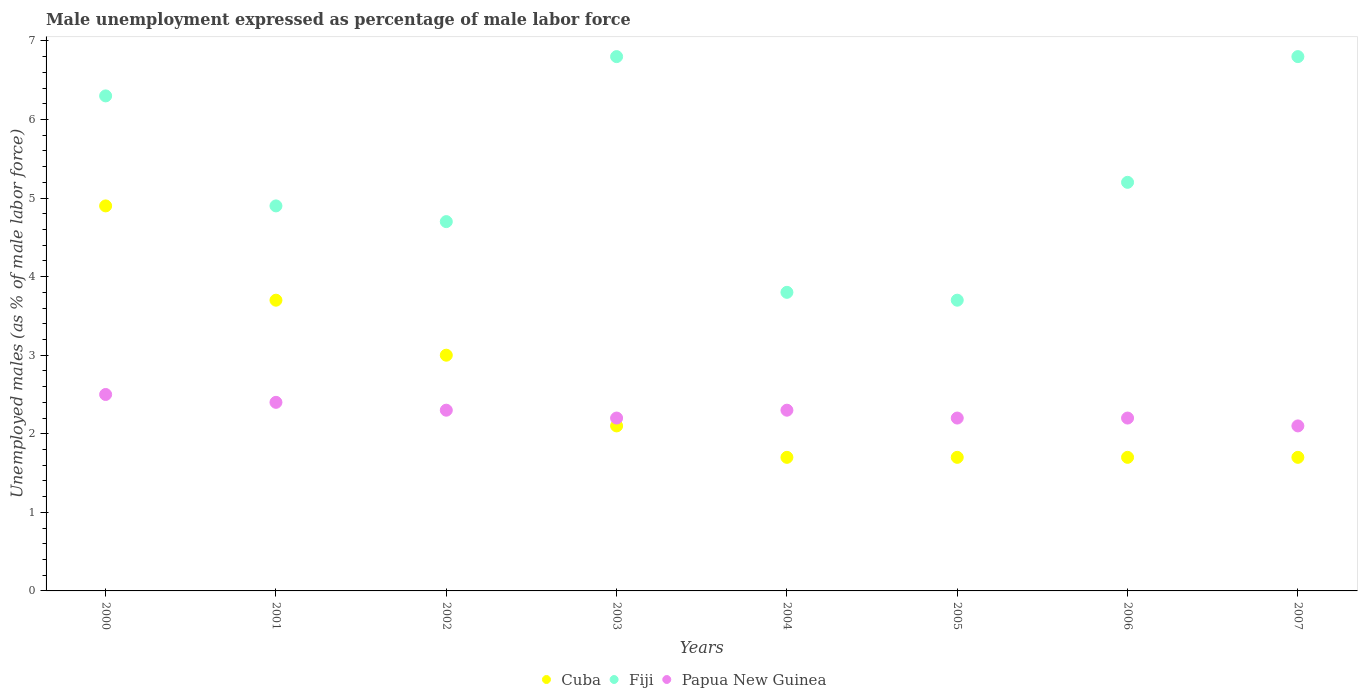How many different coloured dotlines are there?
Your answer should be compact. 3. What is the unemployment in males in in Cuba in 2003?
Give a very brief answer. 2.1. Across all years, what is the maximum unemployment in males in in Fiji?
Offer a terse response. 6.8. Across all years, what is the minimum unemployment in males in in Papua New Guinea?
Provide a succinct answer. 2.1. In which year was the unemployment in males in in Cuba maximum?
Offer a very short reply. 2000. In which year was the unemployment in males in in Fiji minimum?
Provide a short and direct response. 2005. What is the total unemployment in males in in Cuba in the graph?
Offer a very short reply. 20.5. What is the difference between the unemployment in males in in Fiji in 2000 and that in 2001?
Provide a succinct answer. 1.4. What is the difference between the unemployment in males in in Cuba in 2006 and the unemployment in males in in Papua New Guinea in 2005?
Offer a very short reply. -0.5. What is the average unemployment in males in in Papua New Guinea per year?
Your response must be concise. 2.28. In the year 2005, what is the difference between the unemployment in males in in Cuba and unemployment in males in in Papua New Guinea?
Make the answer very short. -0.5. What is the ratio of the unemployment in males in in Cuba in 2002 to that in 2005?
Make the answer very short. 1.76. What is the difference between the highest and the second highest unemployment in males in in Fiji?
Your answer should be very brief. 0. What is the difference between the highest and the lowest unemployment in males in in Fiji?
Make the answer very short. 3.1. Is the sum of the unemployment in males in in Fiji in 2005 and 2006 greater than the maximum unemployment in males in in Papua New Guinea across all years?
Provide a short and direct response. Yes. Where does the legend appear in the graph?
Ensure brevity in your answer.  Bottom center. How many legend labels are there?
Provide a succinct answer. 3. What is the title of the graph?
Keep it short and to the point. Male unemployment expressed as percentage of male labor force. Does "Sub-Saharan Africa (developing only)" appear as one of the legend labels in the graph?
Provide a succinct answer. No. What is the label or title of the X-axis?
Your answer should be very brief. Years. What is the label or title of the Y-axis?
Make the answer very short. Unemployed males (as % of male labor force). What is the Unemployed males (as % of male labor force) in Cuba in 2000?
Give a very brief answer. 4.9. What is the Unemployed males (as % of male labor force) in Fiji in 2000?
Your answer should be very brief. 6.3. What is the Unemployed males (as % of male labor force) of Papua New Guinea in 2000?
Make the answer very short. 2.5. What is the Unemployed males (as % of male labor force) of Cuba in 2001?
Your answer should be very brief. 3.7. What is the Unemployed males (as % of male labor force) of Fiji in 2001?
Your response must be concise. 4.9. What is the Unemployed males (as % of male labor force) in Papua New Guinea in 2001?
Your response must be concise. 2.4. What is the Unemployed males (as % of male labor force) in Cuba in 2002?
Make the answer very short. 3. What is the Unemployed males (as % of male labor force) of Fiji in 2002?
Ensure brevity in your answer.  4.7. What is the Unemployed males (as % of male labor force) of Papua New Guinea in 2002?
Keep it short and to the point. 2.3. What is the Unemployed males (as % of male labor force) in Cuba in 2003?
Make the answer very short. 2.1. What is the Unemployed males (as % of male labor force) of Fiji in 2003?
Your answer should be very brief. 6.8. What is the Unemployed males (as % of male labor force) of Papua New Guinea in 2003?
Ensure brevity in your answer.  2.2. What is the Unemployed males (as % of male labor force) in Cuba in 2004?
Your answer should be compact. 1.7. What is the Unemployed males (as % of male labor force) in Fiji in 2004?
Give a very brief answer. 3.8. What is the Unemployed males (as % of male labor force) in Papua New Guinea in 2004?
Offer a very short reply. 2.3. What is the Unemployed males (as % of male labor force) of Cuba in 2005?
Your response must be concise. 1.7. What is the Unemployed males (as % of male labor force) of Fiji in 2005?
Make the answer very short. 3.7. What is the Unemployed males (as % of male labor force) in Papua New Guinea in 2005?
Make the answer very short. 2.2. What is the Unemployed males (as % of male labor force) of Cuba in 2006?
Offer a terse response. 1.7. What is the Unemployed males (as % of male labor force) in Fiji in 2006?
Make the answer very short. 5.2. What is the Unemployed males (as % of male labor force) of Papua New Guinea in 2006?
Your answer should be very brief. 2.2. What is the Unemployed males (as % of male labor force) in Cuba in 2007?
Ensure brevity in your answer.  1.7. What is the Unemployed males (as % of male labor force) of Fiji in 2007?
Your response must be concise. 6.8. What is the Unemployed males (as % of male labor force) of Papua New Guinea in 2007?
Your answer should be compact. 2.1. Across all years, what is the maximum Unemployed males (as % of male labor force) in Cuba?
Keep it short and to the point. 4.9. Across all years, what is the maximum Unemployed males (as % of male labor force) of Fiji?
Offer a very short reply. 6.8. Across all years, what is the minimum Unemployed males (as % of male labor force) of Cuba?
Provide a short and direct response. 1.7. Across all years, what is the minimum Unemployed males (as % of male labor force) in Fiji?
Make the answer very short. 3.7. Across all years, what is the minimum Unemployed males (as % of male labor force) in Papua New Guinea?
Your answer should be very brief. 2.1. What is the total Unemployed males (as % of male labor force) of Cuba in the graph?
Make the answer very short. 20.5. What is the total Unemployed males (as % of male labor force) of Fiji in the graph?
Provide a succinct answer. 42.2. What is the difference between the Unemployed males (as % of male labor force) of Fiji in 2000 and that in 2001?
Provide a succinct answer. 1.4. What is the difference between the Unemployed males (as % of male labor force) in Papua New Guinea in 2000 and that in 2001?
Keep it short and to the point. 0.1. What is the difference between the Unemployed males (as % of male labor force) in Cuba in 2000 and that in 2002?
Make the answer very short. 1.9. What is the difference between the Unemployed males (as % of male labor force) in Fiji in 2000 and that in 2002?
Offer a terse response. 1.6. What is the difference between the Unemployed males (as % of male labor force) of Papua New Guinea in 2000 and that in 2002?
Your answer should be very brief. 0.2. What is the difference between the Unemployed males (as % of male labor force) in Cuba in 2000 and that in 2004?
Keep it short and to the point. 3.2. What is the difference between the Unemployed males (as % of male labor force) of Fiji in 2000 and that in 2004?
Offer a very short reply. 2.5. What is the difference between the Unemployed males (as % of male labor force) in Papua New Guinea in 2000 and that in 2004?
Your answer should be very brief. 0.2. What is the difference between the Unemployed males (as % of male labor force) of Cuba in 2000 and that in 2005?
Your answer should be compact. 3.2. What is the difference between the Unemployed males (as % of male labor force) of Papua New Guinea in 2000 and that in 2005?
Make the answer very short. 0.3. What is the difference between the Unemployed males (as % of male labor force) of Cuba in 2000 and that in 2006?
Provide a short and direct response. 3.2. What is the difference between the Unemployed males (as % of male labor force) of Cuba in 2000 and that in 2007?
Provide a short and direct response. 3.2. What is the difference between the Unemployed males (as % of male labor force) of Cuba in 2001 and that in 2002?
Give a very brief answer. 0.7. What is the difference between the Unemployed males (as % of male labor force) in Fiji in 2001 and that in 2002?
Provide a short and direct response. 0.2. What is the difference between the Unemployed males (as % of male labor force) in Cuba in 2001 and that in 2003?
Your answer should be compact. 1.6. What is the difference between the Unemployed males (as % of male labor force) in Fiji in 2001 and that in 2004?
Your answer should be compact. 1.1. What is the difference between the Unemployed males (as % of male labor force) of Papua New Guinea in 2001 and that in 2004?
Make the answer very short. 0.1. What is the difference between the Unemployed males (as % of male labor force) in Cuba in 2001 and that in 2005?
Offer a terse response. 2. What is the difference between the Unemployed males (as % of male labor force) of Fiji in 2001 and that in 2005?
Provide a short and direct response. 1.2. What is the difference between the Unemployed males (as % of male labor force) of Cuba in 2001 and that in 2006?
Your answer should be very brief. 2. What is the difference between the Unemployed males (as % of male labor force) in Fiji in 2001 and that in 2007?
Your answer should be very brief. -1.9. What is the difference between the Unemployed males (as % of male labor force) of Fiji in 2002 and that in 2003?
Your response must be concise. -2.1. What is the difference between the Unemployed males (as % of male labor force) in Fiji in 2002 and that in 2004?
Offer a terse response. 0.9. What is the difference between the Unemployed males (as % of male labor force) in Fiji in 2002 and that in 2005?
Keep it short and to the point. 1. What is the difference between the Unemployed males (as % of male labor force) of Papua New Guinea in 2002 and that in 2005?
Provide a succinct answer. 0.1. What is the difference between the Unemployed males (as % of male labor force) in Cuba in 2002 and that in 2006?
Your answer should be very brief. 1.3. What is the difference between the Unemployed males (as % of male labor force) in Fiji in 2002 and that in 2006?
Provide a succinct answer. -0.5. What is the difference between the Unemployed males (as % of male labor force) in Fiji in 2002 and that in 2007?
Offer a very short reply. -2.1. What is the difference between the Unemployed males (as % of male labor force) in Papua New Guinea in 2002 and that in 2007?
Make the answer very short. 0.2. What is the difference between the Unemployed males (as % of male labor force) of Cuba in 2003 and that in 2004?
Make the answer very short. 0.4. What is the difference between the Unemployed males (as % of male labor force) of Papua New Guinea in 2003 and that in 2004?
Provide a short and direct response. -0.1. What is the difference between the Unemployed males (as % of male labor force) of Cuba in 2003 and that in 2005?
Your answer should be compact. 0.4. What is the difference between the Unemployed males (as % of male labor force) in Fiji in 2003 and that in 2005?
Offer a terse response. 3.1. What is the difference between the Unemployed males (as % of male labor force) in Cuba in 2003 and that in 2007?
Give a very brief answer. 0.4. What is the difference between the Unemployed males (as % of male labor force) of Fiji in 2003 and that in 2007?
Provide a succinct answer. 0. What is the difference between the Unemployed males (as % of male labor force) of Papua New Guinea in 2003 and that in 2007?
Your answer should be compact. 0.1. What is the difference between the Unemployed males (as % of male labor force) of Cuba in 2004 and that in 2005?
Your answer should be compact. 0. What is the difference between the Unemployed males (as % of male labor force) of Fiji in 2004 and that in 2005?
Ensure brevity in your answer.  0.1. What is the difference between the Unemployed males (as % of male labor force) in Papua New Guinea in 2004 and that in 2005?
Your answer should be compact. 0.1. What is the difference between the Unemployed males (as % of male labor force) of Papua New Guinea in 2004 and that in 2006?
Give a very brief answer. 0.1. What is the difference between the Unemployed males (as % of male labor force) in Cuba in 2004 and that in 2007?
Provide a succinct answer. 0. What is the difference between the Unemployed males (as % of male labor force) in Fiji in 2004 and that in 2007?
Provide a succinct answer. -3. What is the difference between the Unemployed males (as % of male labor force) of Papua New Guinea in 2005 and that in 2006?
Keep it short and to the point. 0. What is the difference between the Unemployed males (as % of male labor force) of Fiji in 2005 and that in 2007?
Your answer should be very brief. -3.1. What is the difference between the Unemployed males (as % of male labor force) of Cuba in 2006 and that in 2007?
Offer a very short reply. 0. What is the difference between the Unemployed males (as % of male labor force) in Papua New Guinea in 2006 and that in 2007?
Provide a short and direct response. 0.1. What is the difference between the Unemployed males (as % of male labor force) in Cuba in 2000 and the Unemployed males (as % of male labor force) in Fiji in 2001?
Give a very brief answer. 0. What is the difference between the Unemployed males (as % of male labor force) in Cuba in 2000 and the Unemployed males (as % of male labor force) in Papua New Guinea in 2001?
Keep it short and to the point. 2.5. What is the difference between the Unemployed males (as % of male labor force) of Fiji in 2000 and the Unemployed males (as % of male labor force) of Papua New Guinea in 2001?
Ensure brevity in your answer.  3.9. What is the difference between the Unemployed males (as % of male labor force) in Fiji in 2000 and the Unemployed males (as % of male labor force) in Papua New Guinea in 2002?
Give a very brief answer. 4. What is the difference between the Unemployed males (as % of male labor force) in Cuba in 2000 and the Unemployed males (as % of male labor force) in Fiji in 2004?
Provide a succinct answer. 1.1. What is the difference between the Unemployed males (as % of male labor force) in Cuba in 2000 and the Unemployed males (as % of male labor force) in Papua New Guinea in 2004?
Keep it short and to the point. 2.6. What is the difference between the Unemployed males (as % of male labor force) of Fiji in 2000 and the Unemployed males (as % of male labor force) of Papua New Guinea in 2004?
Offer a terse response. 4. What is the difference between the Unemployed males (as % of male labor force) in Cuba in 2000 and the Unemployed males (as % of male labor force) in Fiji in 2005?
Ensure brevity in your answer.  1.2. What is the difference between the Unemployed males (as % of male labor force) of Cuba in 2000 and the Unemployed males (as % of male labor force) of Papua New Guinea in 2005?
Offer a terse response. 2.7. What is the difference between the Unemployed males (as % of male labor force) in Fiji in 2000 and the Unemployed males (as % of male labor force) in Papua New Guinea in 2005?
Your response must be concise. 4.1. What is the difference between the Unemployed males (as % of male labor force) of Cuba in 2000 and the Unemployed males (as % of male labor force) of Fiji in 2006?
Give a very brief answer. -0.3. What is the difference between the Unemployed males (as % of male labor force) in Fiji in 2000 and the Unemployed males (as % of male labor force) in Papua New Guinea in 2006?
Give a very brief answer. 4.1. What is the difference between the Unemployed males (as % of male labor force) in Cuba in 2001 and the Unemployed males (as % of male labor force) in Papua New Guinea in 2002?
Make the answer very short. 1.4. What is the difference between the Unemployed males (as % of male labor force) of Fiji in 2001 and the Unemployed males (as % of male labor force) of Papua New Guinea in 2002?
Offer a very short reply. 2.6. What is the difference between the Unemployed males (as % of male labor force) of Fiji in 2001 and the Unemployed males (as % of male labor force) of Papua New Guinea in 2003?
Provide a succinct answer. 2.7. What is the difference between the Unemployed males (as % of male labor force) of Cuba in 2001 and the Unemployed males (as % of male labor force) of Fiji in 2005?
Your response must be concise. 0. What is the difference between the Unemployed males (as % of male labor force) in Cuba in 2001 and the Unemployed males (as % of male labor force) in Papua New Guinea in 2005?
Offer a terse response. 1.5. What is the difference between the Unemployed males (as % of male labor force) of Fiji in 2001 and the Unemployed males (as % of male labor force) of Papua New Guinea in 2005?
Give a very brief answer. 2.7. What is the difference between the Unemployed males (as % of male labor force) in Cuba in 2001 and the Unemployed males (as % of male labor force) in Fiji in 2006?
Give a very brief answer. -1.5. What is the difference between the Unemployed males (as % of male labor force) in Cuba in 2001 and the Unemployed males (as % of male labor force) in Papua New Guinea in 2006?
Your answer should be very brief. 1.5. What is the difference between the Unemployed males (as % of male labor force) in Cuba in 2001 and the Unemployed males (as % of male labor force) in Fiji in 2007?
Provide a short and direct response. -3.1. What is the difference between the Unemployed males (as % of male labor force) in Fiji in 2001 and the Unemployed males (as % of male labor force) in Papua New Guinea in 2007?
Your answer should be very brief. 2.8. What is the difference between the Unemployed males (as % of male labor force) of Cuba in 2002 and the Unemployed males (as % of male labor force) of Fiji in 2003?
Keep it short and to the point. -3.8. What is the difference between the Unemployed males (as % of male labor force) of Cuba in 2002 and the Unemployed males (as % of male labor force) of Papua New Guinea in 2003?
Provide a succinct answer. 0.8. What is the difference between the Unemployed males (as % of male labor force) in Fiji in 2002 and the Unemployed males (as % of male labor force) in Papua New Guinea in 2003?
Ensure brevity in your answer.  2.5. What is the difference between the Unemployed males (as % of male labor force) of Cuba in 2002 and the Unemployed males (as % of male labor force) of Fiji in 2004?
Your answer should be compact. -0.8. What is the difference between the Unemployed males (as % of male labor force) of Fiji in 2002 and the Unemployed males (as % of male labor force) of Papua New Guinea in 2004?
Your answer should be very brief. 2.4. What is the difference between the Unemployed males (as % of male labor force) in Cuba in 2002 and the Unemployed males (as % of male labor force) in Fiji in 2005?
Keep it short and to the point. -0.7. What is the difference between the Unemployed males (as % of male labor force) of Cuba in 2002 and the Unemployed males (as % of male labor force) of Papua New Guinea in 2006?
Your answer should be very brief. 0.8. What is the difference between the Unemployed males (as % of male labor force) in Cuba in 2003 and the Unemployed males (as % of male labor force) in Fiji in 2004?
Provide a short and direct response. -1.7. What is the difference between the Unemployed males (as % of male labor force) of Cuba in 2003 and the Unemployed males (as % of male labor force) of Papua New Guinea in 2006?
Offer a very short reply. -0.1. What is the difference between the Unemployed males (as % of male labor force) in Cuba in 2003 and the Unemployed males (as % of male labor force) in Fiji in 2007?
Keep it short and to the point. -4.7. What is the difference between the Unemployed males (as % of male labor force) in Cuba in 2004 and the Unemployed males (as % of male labor force) in Fiji in 2005?
Provide a short and direct response. -2. What is the difference between the Unemployed males (as % of male labor force) in Cuba in 2004 and the Unemployed males (as % of male labor force) in Papua New Guinea in 2005?
Offer a very short reply. -0.5. What is the difference between the Unemployed males (as % of male labor force) in Fiji in 2004 and the Unemployed males (as % of male labor force) in Papua New Guinea in 2005?
Ensure brevity in your answer.  1.6. What is the difference between the Unemployed males (as % of male labor force) of Cuba in 2004 and the Unemployed males (as % of male labor force) of Papua New Guinea in 2006?
Ensure brevity in your answer.  -0.5. What is the difference between the Unemployed males (as % of male labor force) of Fiji in 2004 and the Unemployed males (as % of male labor force) of Papua New Guinea in 2006?
Provide a short and direct response. 1.6. What is the difference between the Unemployed males (as % of male labor force) of Cuba in 2004 and the Unemployed males (as % of male labor force) of Papua New Guinea in 2007?
Provide a succinct answer. -0.4. What is the difference between the Unemployed males (as % of male labor force) of Fiji in 2004 and the Unemployed males (as % of male labor force) of Papua New Guinea in 2007?
Ensure brevity in your answer.  1.7. What is the difference between the Unemployed males (as % of male labor force) in Cuba in 2005 and the Unemployed males (as % of male labor force) in Fiji in 2006?
Your answer should be compact. -3.5. What is the difference between the Unemployed males (as % of male labor force) of Cuba in 2005 and the Unemployed males (as % of male labor force) of Fiji in 2007?
Give a very brief answer. -5.1. What is the difference between the Unemployed males (as % of male labor force) of Cuba in 2005 and the Unemployed males (as % of male labor force) of Papua New Guinea in 2007?
Your response must be concise. -0.4. What is the difference between the Unemployed males (as % of male labor force) in Cuba in 2006 and the Unemployed males (as % of male labor force) in Fiji in 2007?
Make the answer very short. -5.1. What is the difference between the Unemployed males (as % of male labor force) in Cuba in 2006 and the Unemployed males (as % of male labor force) in Papua New Guinea in 2007?
Give a very brief answer. -0.4. What is the average Unemployed males (as % of male labor force) in Cuba per year?
Offer a very short reply. 2.56. What is the average Unemployed males (as % of male labor force) in Fiji per year?
Keep it short and to the point. 5.28. What is the average Unemployed males (as % of male labor force) in Papua New Guinea per year?
Your response must be concise. 2.27. In the year 2000, what is the difference between the Unemployed males (as % of male labor force) in Cuba and Unemployed males (as % of male labor force) in Papua New Guinea?
Your answer should be very brief. 2.4. In the year 2000, what is the difference between the Unemployed males (as % of male labor force) of Fiji and Unemployed males (as % of male labor force) of Papua New Guinea?
Ensure brevity in your answer.  3.8. In the year 2002, what is the difference between the Unemployed males (as % of male labor force) in Cuba and Unemployed males (as % of male labor force) in Papua New Guinea?
Keep it short and to the point. 0.7. In the year 2002, what is the difference between the Unemployed males (as % of male labor force) of Fiji and Unemployed males (as % of male labor force) of Papua New Guinea?
Your response must be concise. 2.4. In the year 2003, what is the difference between the Unemployed males (as % of male labor force) of Cuba and Unemployed males (as % of male labor force) of Papua New Guinea?
Give a very brief answer. -0.1. In the year 2003, what is the difference between the Unemployed males (as % of male labor force) of Fiji and Unemployed males (as % of male labor force) of Papua New Guinea?
Give a very brief answer. 4.6. In the year 2004, what is the difference between the Unemployed males (as % of male labor force) of Cuba and Unemployed males (as % of male labor force) of Papua New Guinea?
Keep it short and to the point. -0.6. In the year 2004, what is the difference between the Unemployed males (as % of male labor force) of Fiji and Unemployed males (as % of male labor force) of Papua New Guinea?
Make the answer very short. 1.5. In the year 2005, what is the difference between the Unemployed males (as % of male labor force) in Cuba and Unemployed males (as % of male labor force) in Fiji?
Ensure brevity in your answer.  -2. In the year 2005, what is the difference between the Unemployed males (as % of male labor force) of Fiji and Unemployed males (as % of male labor force) of Papua New Guinea?
Keep it short and to the point. 1.5. In the year 2006, what is the difference between the Unemployed males (as % of male labor force) in Fiji and Unemployed males (as % of male labor force) in Papua New Guinea?
Keep it short and to the point. 3. In the year 2007, what is the difference between the Unemployed males (as % of male labor force) in Cuba and Unemployed males (as % of male labor force) in Papua New Guinea?
Offer a terse response. -0.4. What is the ratio of the Unemployed males (as % of male labor force) in Cuba in 2000 to that in 2001?
Your response must be concise. 1.32. What is the ratio of the Unemployed males (as % of male labor force) in Papua New Guinea in 2000 to that in 2001?
Ensure brevity in your answer.  1.04. What is the ratio of the Unemployed males (as % of male labor force) of Cuba in 2000 to that in 2002?
Make the answer very short. 1.63. What is the ratio of the Unemployed males (as % of male labor force) in Fiji in 2000 to that in 2002?
Make the answer very short. 1.34. What is the ratio of the Unemployed males (as % of male labor force) of Papua New Guinea in 2000 to that in 2002?
Ensure brevity in your answer.  1.09. What is the ratio of the Unemployed males (as % of male labor force) in Cuba in 2000 to that in 2003?
Ensure brevity in your answer.  2.33. What is the ratio of the Unemployed males (as % of male labor force) in Fiji in 2000 to that in 2003?
Your response must be concise. 0.93. What is the ratio of the Unemployed males (as % of male labor force) of Papua New Guinea in 2000 to that in 2003?
Keep it short and to the point. 1.14. What is the ratio of the Unemployed males (as % of male labor force) of Cuba in 2000 to that in 2004?
Ensure brevity in your answer.  2.88. What is the ratio of the Unemployed males (as % of male labor force) of Fiji in 2000 to that in 2004?
Your answer should be very brief. 1.66. What is the ratio of the Unemployed males (as % of male labor force) in Papua New Guinea in 2000 to that in 2004?
Give a very brief answer. 1.09. What is the ratio of the Unemployed males (as % of male labor force) of Cuba in 2000 to that in 2005?
Provide a short and direct response. 2.88. What is the ratio of the Unemployed males (as % of male labor force) in Fiji in 2000 to that in 2005?
Give a very brief answer. 1.7. What is the ratio of the Unemployed males (as % of male labor force) of Papua New Guinea in 2000 to that in 2005?
Your answer should be compact. 1.14. What is the ratio of the Unemployed males (as % of male labor force) of Cuba in 2000 to that in 2006?
Your answer should be very brief. 2.88. What is the ratio of the Unemployed males (as % of male labor force) of Fiji in 2000 to that in 2006?
Ensure brevity in your answer.  1.21. What is the ratio of the Unemployed males (as % of male labor force) in Papua New Guinea in 2000 to that in 2006?
Make the answer very short. 1.14. What is the ratio of the Unemployed males (as % of male labor force) of Cuba in 2000 to that in 2007?
Ensure brevity in your answer.  2.88. What is the ratio of the Unemployed males (as % of male labor force) of Fiji in 2000 to that in 2007?
Offer a terse response. 0.93. What is the ratio of the Unemployed males (as % of male labor force) of Papua New Guinea in 2000 to that in 2007?
Provide a succinct answer. 1.19. What is the ratio of the Unemployed males (as % of male labor force) in Cuba in 2001 to that in 2002?
Offer a terse response. 1.23. What is the ratio of the Unemployed males (as % of male labor force) in Fiji in 2001 to that in 2002?
Provide a short and direct response. 1.04. What is the ratio of the Unemployed males (as % of male labor force) of Papua New Guinea in 2001 to that in 2002?
Ensure brevity in your answer.  1.04. What is the ratio of the Unemployed males (as % of male labor force) of Cuba in 2001 to that in 2003?
Your response must be concise. 1.76. What is the ratio of the Unemployed males (as % of male labor force) of Fiji in 2001 to that in 2003?
Offer a terse response. 0.72. What is the ratio of the Unemployed males (as % of male labor force) of Papua New Guinea in 2001 to that in 2003?
Provide a succinct answer. 1.09. What is the ratio of the Unemployed males (as % of male labor force) of Cuba in 2001 to that in 2004?
Offer a terse response. 2.18. What is the ratio of the Unemployed males (as % of male labor force) in Fiji in 2001 to that in 2004?
Keep it short and to the point. 1.29. What is the ratio of the Unemployed males (as % of male labor force) of Papua New Guinea in 2001 to that in 2004?
Offer a terse response. 1.04. What is the ratio of the Unemployed males (as % of male labor force) of Cuba in 2001 to that in 2005?
Your response must be concise. 2.18. What is the ratio of the Unemployed males (as % of male labor force) in Fiji in 2001 to that in 2005?
Your answer should be very brief. 1.32. What is the ratio of the Unemployed males (as % of male labor force) in Cuba in 2001 to that in 2006?
Ensure brevity in your answer.  2.18. What is the ratio of the Unemployed males (as % of male labor force) of Fiji in 2001 to that in 2006?
Give a very brief answer. 0.94. What is the ratio of the Unemployed males (as % of male labor force) in Cuba in 2001 to that in 2007?
Offer a very short reply. 2.18. What is the ratio of the Unemployed males (as % of male labor force) of Fiji in 2001 to that in 2007?
Provide a succinct answer. 0.72. What is the ratio of the Unemployed males (as % of male labor force) of Cuba in 2002 to that in 2003?
Your answer should be compact. 1.43. What is the ratio of the Unemployed males (as % of male labor force) in Fiji in 2002 to that in 2003?
Provide a succinct answer. 0.69. What is the ratio of the Unemployed males (as % of male labor force) in Papua New Guinea in 2002 to that in 2003?
Provide a short and direct response. 1.05. What is the ratio of the Unemployed males (as % of male labor force) in Cuba in 2002 to that in 2004?
Your answer should be very brief. 1.76. What is the ratio of the Unemployed males (as % of male labor force) of Fiji in 2002 to that in 2004?
Ensure brevity in your answer.  1.24. What is the ratio of the Unemployed males (as % of male labor force) in Papua New Guinea in 2002 to that in 2004?
Provide a succinct answer. 1. What is the ratio of the Unemployed males (as % of male labor force) in Cuba in 2002 to that in 2005?
Offer a very short reply. 1.76. What is the ratio of the Unemployed males (as % of male labor force) of Fiji in 2002 to that in 2005?
Provide a succinct answer. 1.27. What is the ratio of the Unemployed males (as % of male labor force) of Papua New Guinea in 2002 to that in 2005?
Make the answer very short. 1.05. What is the ratio of the Unemployed males (as % of male labor force) in Cuba in 2002 to that in 2006?
Your response must be concise. 1.76. What is the ratio of the Unemployed males (as % of male labor force) in Fiji in 2002 to that in 2006?
Offer a terse response. 0.9. What is the ratio of the Unemployed males (as % of male labor force) in Papua New Guinea in 2002 to that in 2006?
Make the answer very short. 1.05. What is the ratio of the Unemployed males (as % of male labor force) of Cuba in 2002 to that in 2007?
Your response must be concise. 1.76. What is the ratio of the Unemployed males (as % of male labor force) in Fiji in 2002 to that in 2007?
Ensure brevity in your answer.  0.69. What is the ratio of the Unemployed males (as % of male labor force) of Papua New Guinea in 2002 to that in 2007?
Offer a very short reply. 1.1. What is the ratio of the Unemployed males (as % of male labor force) in Cuba in 2003 to that in 2004?
Keep it short and to the point. 1.24. What is the ratio of the Unemployed males (as % of male labor force) in Fiji in 2003 to that in 2004?
Your response must be concise. 1.79. What is the ratio of the Unemployed males (as % of male labor force) of Papua New Guinea in 2003 to that in 2004?
Your response must be concise. 0.96. What is the ratio of the Unemployed males (as % of male labor force) of Cuba in 2003 to that in 2005?
Offer a very short reply. 1.24. What is the ratio of the Unemployed males (as % of male labor force) in Fiji in 2003 to that in 2005?
Your response must be concise. 1.84. What is the ratio of the Unemployed males (as % of male labor force) of Papua New Guinea in 2003 to that in 2005?
Offer a very short reply. 1. What is the ratio of the Unemployed males (as % of male labor force) in Cuba in 2003 to that in 2006?
Your answer should be very brief. 1.24. What is the ratio of the Unemployed males (as % of male labor force) in Fiji in 2003 to that in 2006?
Make the answer very short. 1.31. What is the ratio of the Unemployed males (as % of male labor force) in Cuba in 2003 to that in 2007?
Your response must be concise. 1.24. What is the ratio of the Unemployed males (as % of male labor force) of Papua New Guinea in 2003 to that in 2007?
Your answer should be compact. 1.05. What is the ratio of the Unemployed males (as % of male labor force) of Papua New Guinea in 2004 to that in 2005?
Your answer should be compact. 1.05. What is the ratio of the Unemployed males (as % of male labor force) in Cuba in 2004 to that in 2006?
Keep it short and to the point. 1. What is the ratio of the Unemployed males (as % of male labor force) in Fiji in 2004 to that in 2006?
Provide a succinct answer. 0.73. What is the ratio of the Unemployed males (as % of male labor force) of Papua New Guinea in 2004 to that in 2006?
Keep it short and to the point. 1.05. What is the ratio of the Unemployed males (as % of male labor force) in Cuba in 2004 to that in 2007?
Ensure brevity in your answer.  1. What is the ratio of the Unemployed males (as % of male labor force) of Fiji in 2004 to that in 2007?
Your answer should be compact. 0.56. What is the ratio of the Unemployed males (as % of male labor force) of Papua New Guinea in 2004 to that in 2007?
Provide a succinct answer. 1.1. What is the ratio of the Unemployed males (as % of male labor force) of Fiji in 2005 to that in 2006?
Your response must be concise. 0.71. What is the ratio of the Unemployed males (as % of male labor force) of Papua New Guinea in 2005 to that in 2006?
Your answer should be very brief. 1. What is the ratio of the Unemployed males (as % of male labor force) of Cuba in 2005 to that in 2007?
Provide a succinct answer. 1. What is the ratio of the Unemployed males (as % of male labor force) of Fiji in 2005 to that in 2007?
Your response must be concise. 0.54. What is the ratio of the Unemployed males (as % of male labor force) in Papua New Guinea in 2005 to that in 2007?
Provide a succinct answer. 1.05. What is the ratio of the Unemployed males (as % of male labor force) of Fiji in 2006 to that in 2007?
Keep it short and to the point. 0.76. What is the ratio of the Unemployed males (as % of male labor force) of Papua New Guinea in 2006 to that in 2007?
Offer a terse response. 1.05. What is the difference between the highest and the second highest Unemployed males (as % of male labor force) of Papua New Guinea?
Provide a short and direct response. 0.1. What is the difference between the highest and the lowest Unemployed males (as % of male labor force) in Fiji?
Provide a short and direct response. 3.1. What is the difference between the highest and the lowest Unemployed males (as % of male labor force) in Papua New Guinea?
Your answer should be compact. 0.4. 